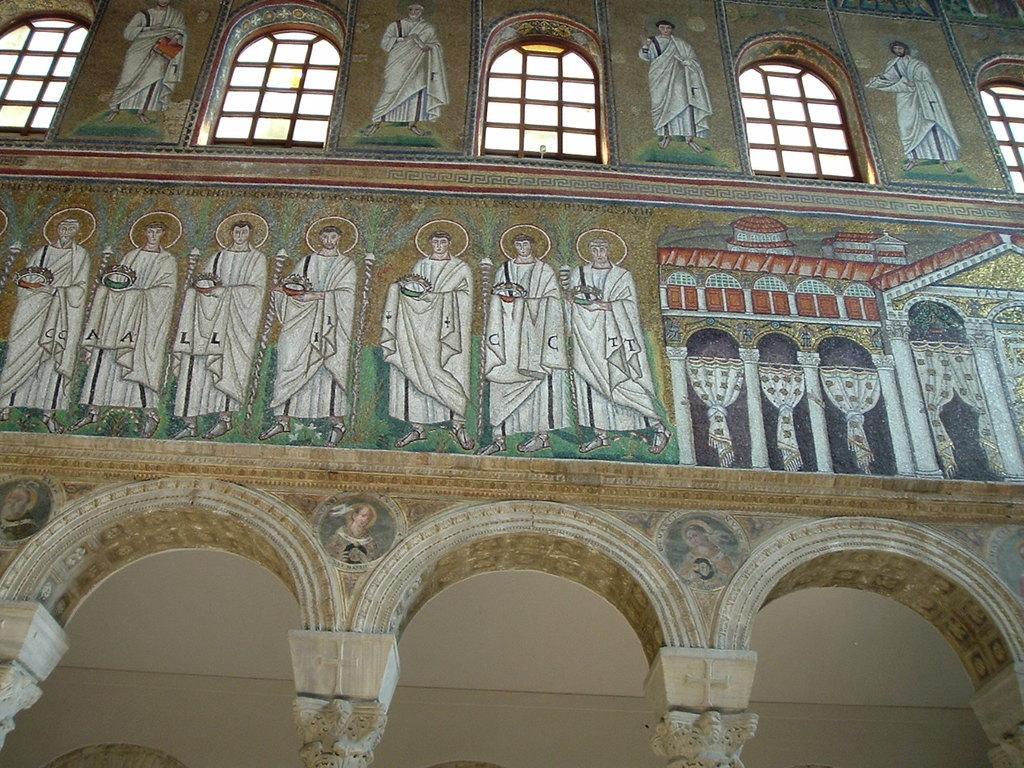In one or two sentences, can you explain what this image depicts? There are arches at the bottom side of the image, painting on the wall and windows at the top side. 